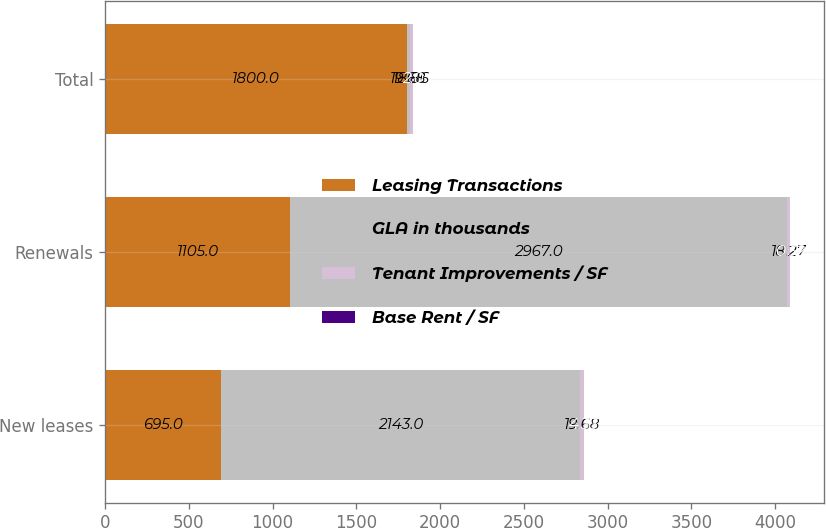Convert chart. <chart><loc_0><loc_0><loc_500><loc_500><stacked_bar_chart><ecel><fcel>New leases<fcel>Renewals<fcel>Total<nl><fcel>Leasing Transactions<fcel>695<fcel>1105<fcel>1800<nl><fcel>GLA in thousands<fcel>2143<fcel>2967<fcel>19.68<nl><fcel>Tenant Improvements / SF<fcel>19.68<fcel>18.27<fcel>18.86<nl><fcel>Base Rent / SF<fcel>4.33<fcel>0.32<fcel>2<nl></chart> 